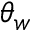Convert formula to latex. <formula><loc_0><loc_0><loc_500><loc_500>\theta _ { w }</formula> 